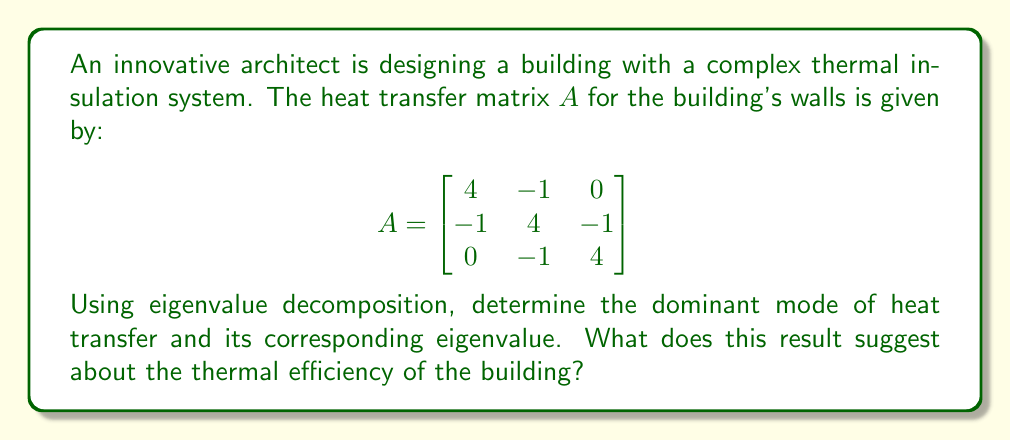Provide a solution to this math problem. To solve this problem, we'll follow these steps:

1) Find the eigenvalues of matrix $A$.
2) Find the eigenvectors corresponding to these eigenvalues.
3) Identify the dominant mode of heat transfer.
4) Interpret the results.

Step 1: Find the eigenvalues

To find the eigenvalues, we solve the characteristic equation:
$$\det(A - \lambda I) = 0$$

$$\begin{vmatrix}
4-\lambda & -1 & 0 \\
-1 & 4-\lambda & -1 \\
0 & -1 & 4-\lambda
\end{vmatrix} = 0$$

Expanding this determinant:
$$(4-\lambda)[(4-\lambda)(4-\lambda) - 1] - (-1)[-1(4-\lambda) - 0] = 0$$
$$(4-\lambda)[16-8\lambda+\lambda^2 - 1] + (4-\lambda) = 0$$
$$(4-\lambda)(\lambda^2-8\lambda+15) + (4-\lambda) = 0$$
$$\lambda^3 - 12\lambda^2 + 44\lambda - 48 = 0$$

The roots of this equation are $\lambda_1 = 2$, $\lambda_2 = 4$, and $\lambda_3 = 6$.

Step 2: Find the eigenvectors

For $\lambda_1 = 2$:
$$(A - 2I)\mathbf{v}_1 = \mathbf{0}$$
Solving this gives $\mathbf{v}_1 = [1, -2, 1]^T$

For $\lambda_2 = 4$:
$$(A - 4I)\mathbf{v}_2 = \mathbf{0}$$
Solving this gives $\mathbf{v}_2 = [1, 0, -1]^T$

For $\lambda_3 = 6$:
$$(A - 6I)\mathbf{v}_3 = \mathbf{0}$$
Solving this gives $\mathbf{v}_3 = [1, 2, 1]^T$

Step 3: Identify the dominant mode

The dominant mode of heat transfer corresponds to the eigenvector with the largest eigenvalue. In this case, it's $\lambda_3 = 6$ with eigenvector $\mathbf{v}_3 = [1, 2, 1]^T$.

Step 4: Interpret the results

The dominant mode $\mathbf{v}_3 = [1, 2, 1]^T$ suggests that heat transfer is strongest in the middle layer of the wall (represented by the 2), with equal but lesser transfer in the outer layers (represented by the 1's). The corresponding eigenvalue of 6 indicates the rate of this heat transfer mode.
Answer: Dominant mode: $[1, 2, 1]^T$, Eigenvalue: 6. Suggests highest heat transfer in the middle layer, indicating potential for improved insulation there to enhance overall thermal efficiency. 